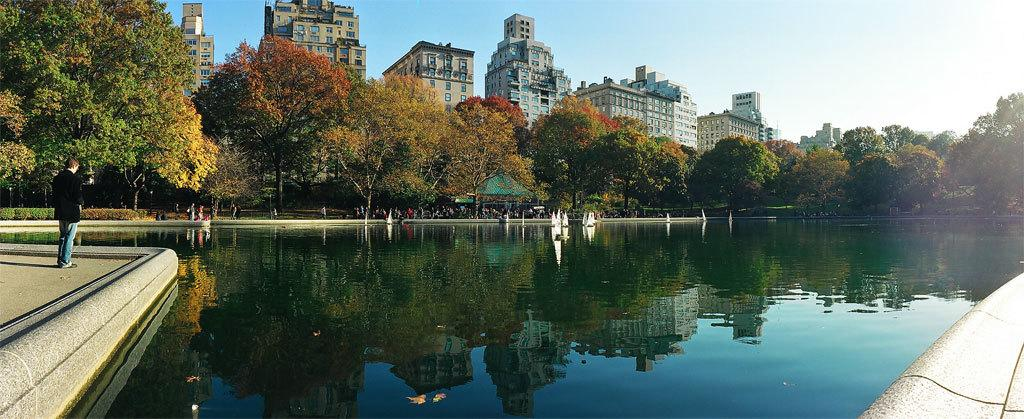What is the main subject of the image? There is a person standing in the image. What is the person looking at? The person is looking at a pool of water. What can be seen on the other side of the water? There are trees and buildings on the other side of the water. What type of fog can be seen around the person in the image? There is no fog present in the image; it is a clear scene with a person looking at a pool of water. 